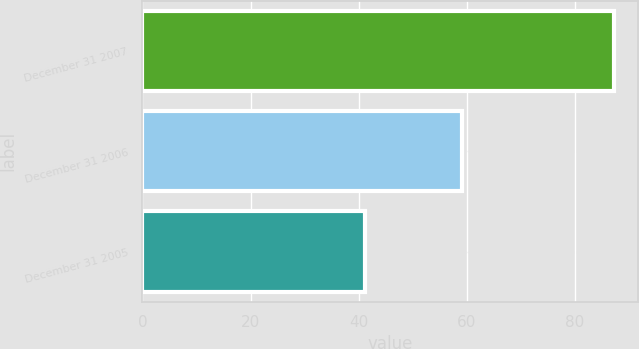<chart> <loc_0><loc_0><loc_500><loc_500><bar_chart><fcel>December 31 2007<fcel>December 31 2006<fcel>December 31 2005<nl><fcel>87.3<fcel>59.1<fcel>41.1<nl></chart> 